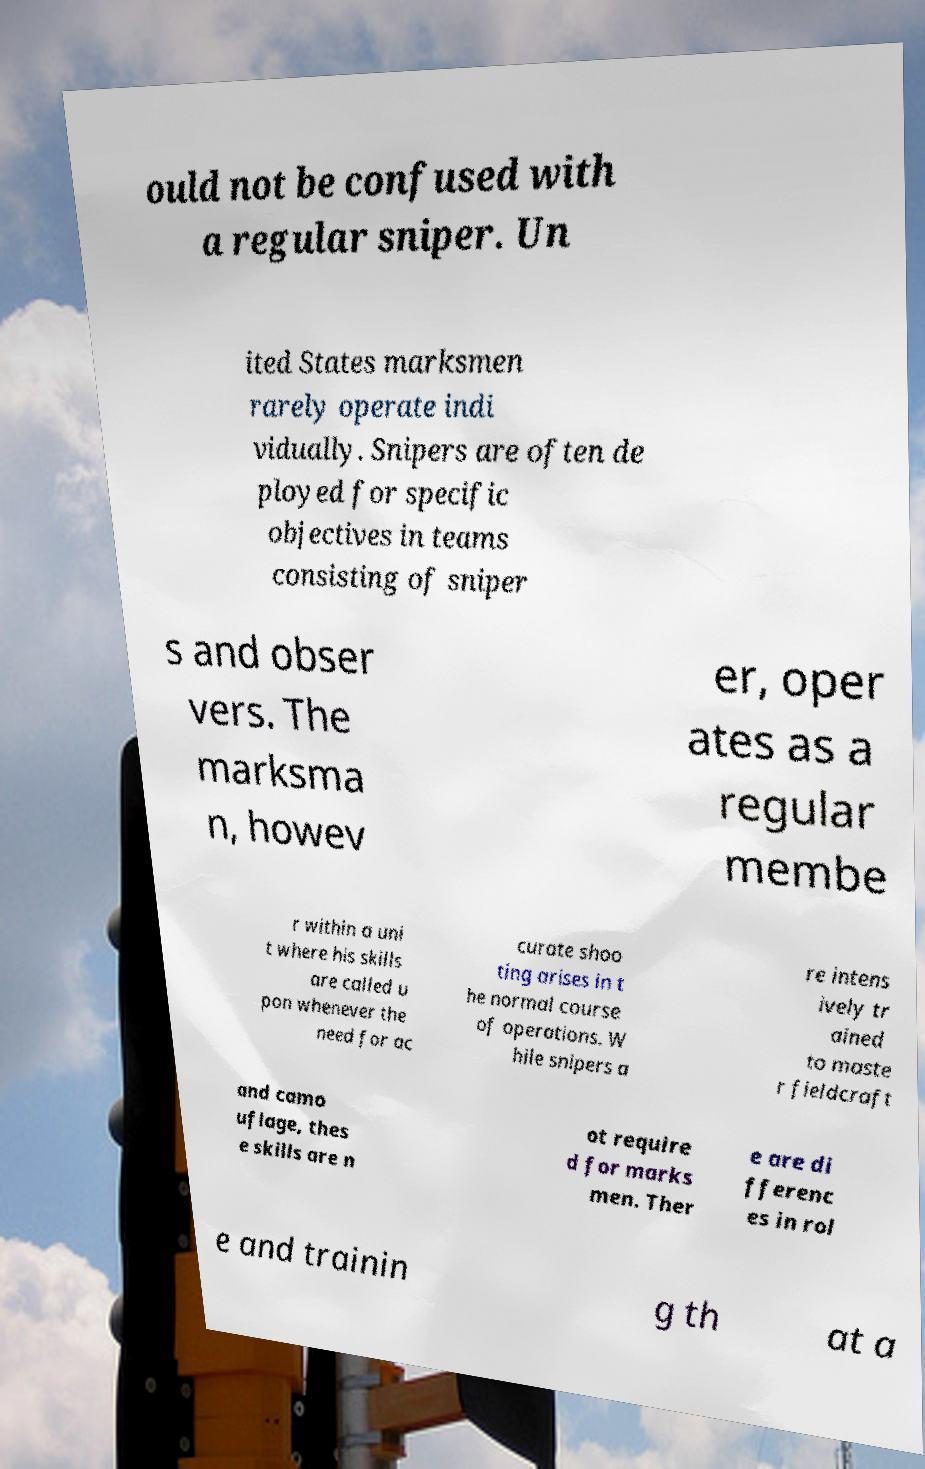Could you assist in decoding the text presented in this image and type it out clearly? ould not be confused with a regular sniper. Un ited States marksmen rarely operate indi vidually. Snipers are often de ployed for specific objectives in teams consisting of sniper s and obser vers. The marksma n, howev er, oper ates as a regular membe r within a uni t where his skills are called u pon whenever the need for ac curate shoo ting arises in t he normal course of operations. W hile snipers a re intens ively tr ained to maste r fieldcraft and camo uflage, thes e skills are n ot require d for marks men. Ther e are di fferenc es in rol e and trainin g th at a 